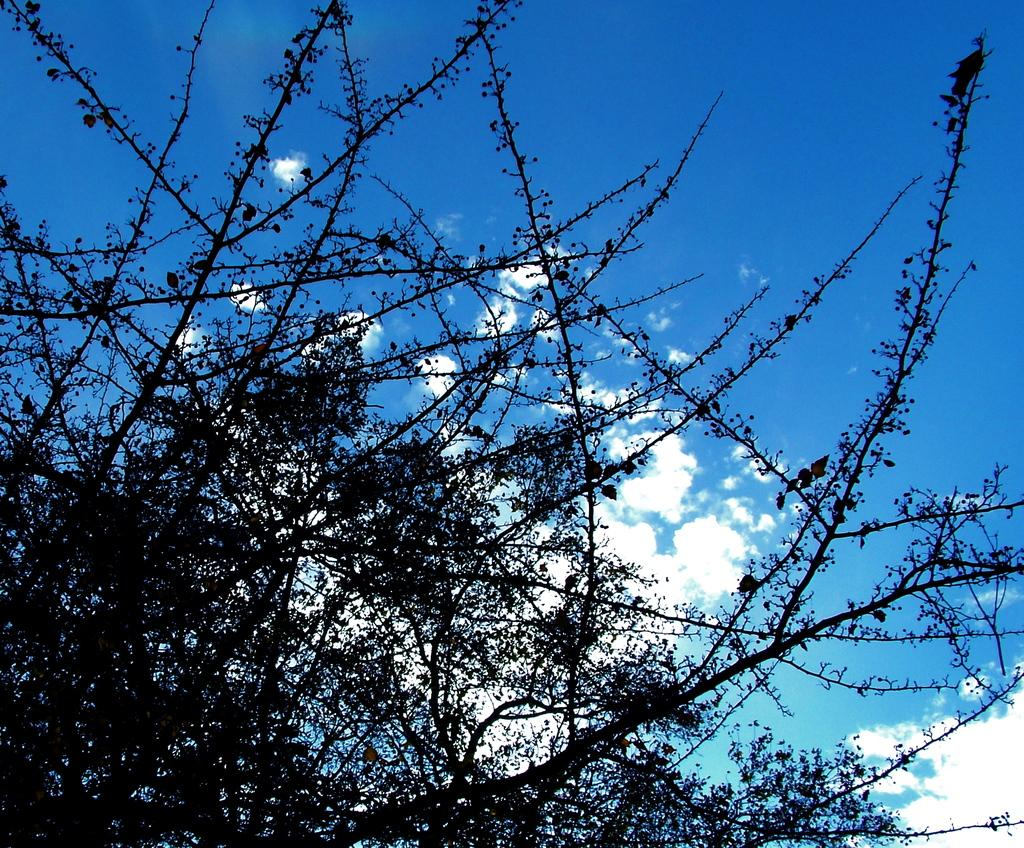What type of living organisms can be seen in the image? Plants can be seen in the image. What are the main features of the plants? The plants have stems and leaves. What is visible in the background of the image? Sky is visible in the image. What can be seen in the sky? There are clouds in the sky. What type of teeth can be seen on the plants in the image? There are no teeth present on the plants in the image, as plants do not have teeth. 